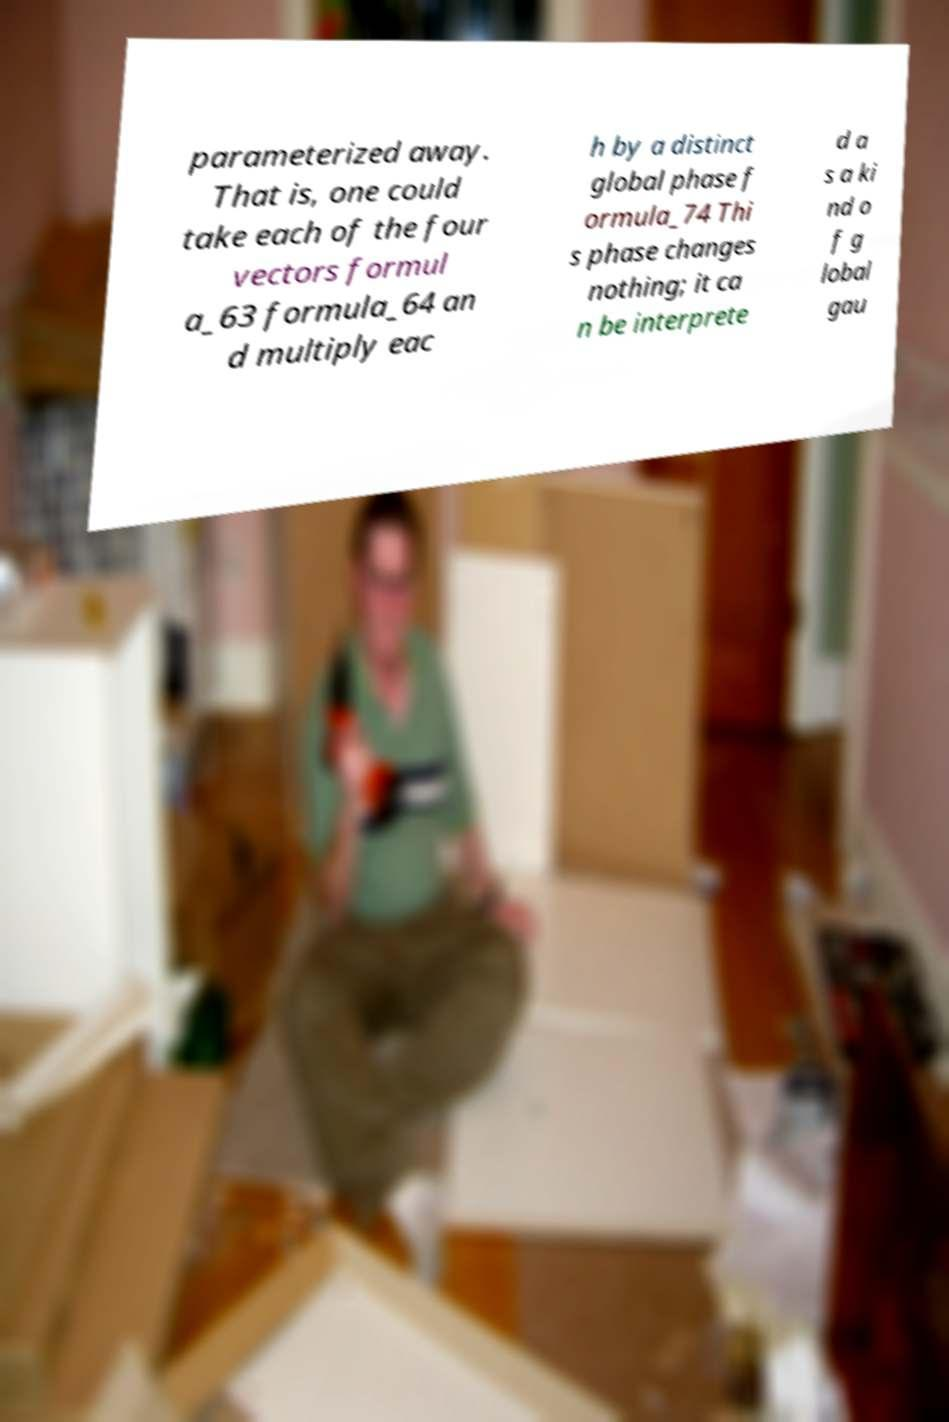For documentation purposes, I need the text within this image transcribed. Could you provide that? parameterized away. That is, one could take each of the four vectors formul a_63 formula_64 an d multiply eac h by a distinct global phase f ormula_74 Thi s phase changes nothing; it ca n be interprete d a s a ki nd o f g lobal gau 